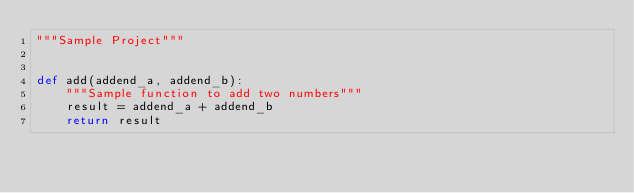<code> <loc_0><loc_0><loc_500><loc_500><_Python_>"""Sample Project"""


def add(addend_a, addend_b):
    """Sample function to add two numbers"""
    result = addend_a + addend_b
    return result
</code> 